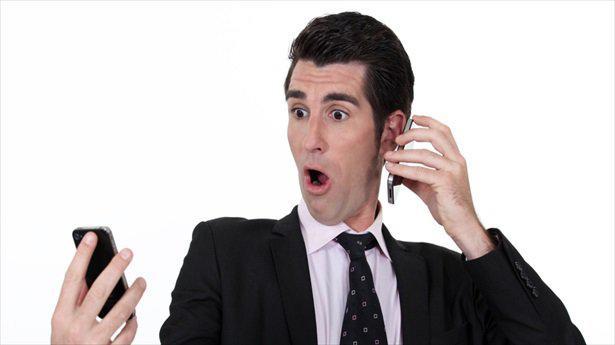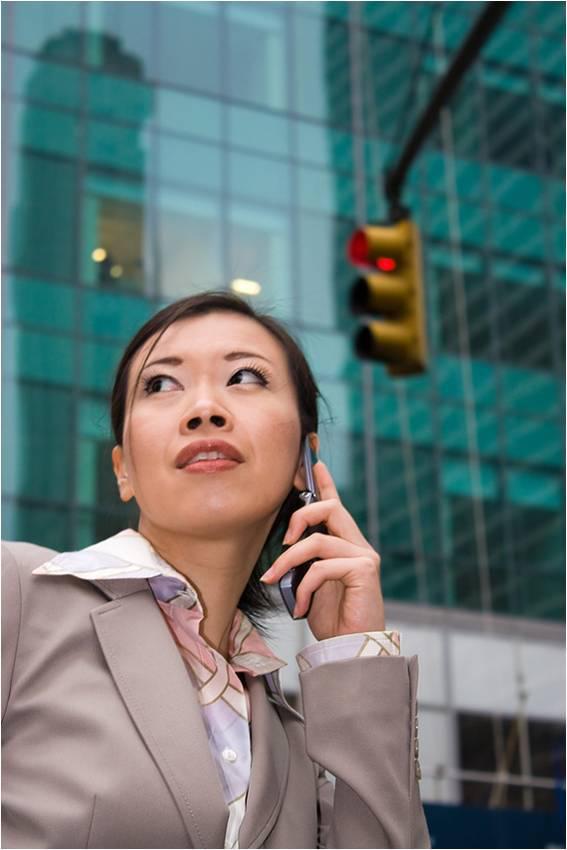The first image is the image on the left, the second image is the image on the right. Given the left and right images, does the statement "A person is holding two phones in the right image." hold true? Answer yes or no. No. The first image is the image on the left, the second image is the image on the right. Analyze the images presented: Is the assertion "Three or more humans are visible." valid? Answer yes or no. No. 